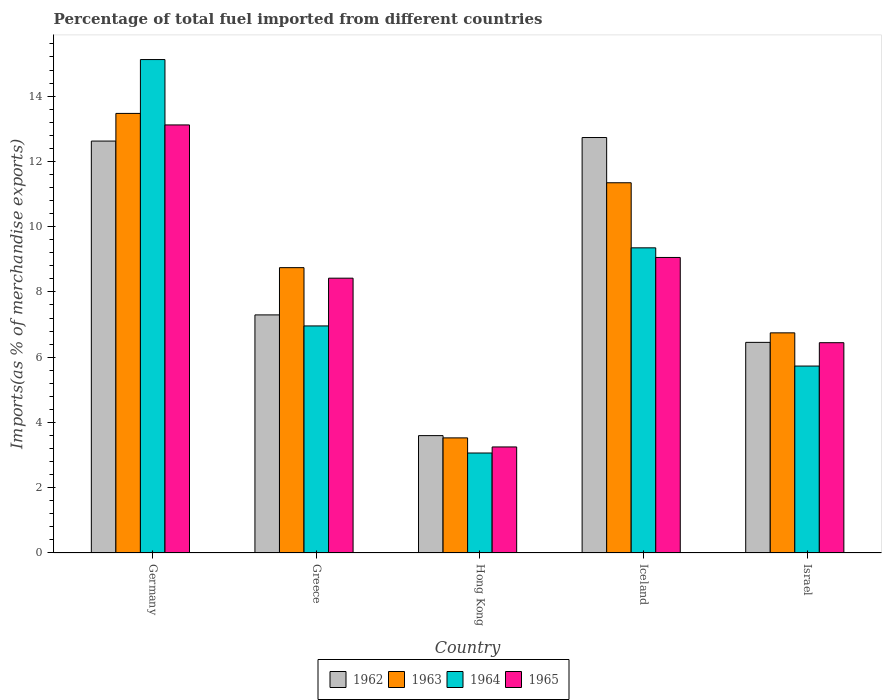How many groups of bars are there?
Provide a succinct answer. 5. Are the number of bars on each tick of the X-axis equal?
Make the answer very short. Yes. In how many cases, is the number of bars for a given country not equal to the number of legend labels?
Offer a very short reply. 0. What is the percentage of imports to different countries in 1962 in Germany?
Your response must be concise. 12.62. Across all countries, what is the maximum percentage of imports to different countries in 1965?
Provide a succinct answer. 13.12. Across all countries, what is the minimum percentage of imports to different countries in 1965?
Provide a succinct answer. 3.25. In which country was the percentage of imports to different countries in 1965 minimum?
Your answer should be compact. Hong Kong. What is the total percentage of imports to different countries in 1962 in the graph?
Offer a terse response. 42.7. What is the difference between the percentage of imports to different countries in 1962 in Greece and that in Israel?
Your response must be concise. 0.84. What is the difference between the percentage of imports to different countries in 1965 in Hong Kong and the percentage of imports to different countries in 1964 in Greece?
Your answer should be very brief. -3.71. What is the average percentage of imports to different countries in 1962 per country?
Your answer should be compact. 8.54. What is the difference between the percentage of imports to different countries of/in 1963 and percentage of imports to different countries of/in 1964 in Iceland?
Your response must be concise. 1.99. In how many countries, is the percentage of imports to different countries in 1963 greater than 7.2 %?
Make the answer very short. 3. What is the ratio of the percentage of imports to different countries in 1964 in Germany to that in Iceland?
Your answer should be very brief. 1.62. Is the difference between the percentage of imports to different countries in 1963 in Greece and Hong Kong greater than the difference between the percentage of imports to different countries in 1964 in Greece and Hong Kong?
Offer a very short reply. Yes. What is the difference between the highest and the second highest percentage of imports to different countries in 1964?
Provide a succinct answer. 2.39. What is the difference between the highest and the lowest percentage of imports to different countries in 1965?
Ensure brevity in your answer.  9.87. In how many countries, is the percentage of imports to different countries in 1965 greater than the average percentage of imports to different countries in 1965 taken over all countries?
Provide a succinct answer. 3. Is the sum of the percentage of imports to different countries in 1963 in Greece and Israel greater than the maximum percentage of imports to different countries in 1964 across all countries?
Keep it short and to the point. Yes. Is it the case that in every country, the sum of the percentage of imports to different countries in 1965 and percentage of imports to different countries in 1963 is greater than the sum of percentage of imports to different countries in 1964 and percentage of imports to different countries in 1962?
Ensure brevity in your answer.  No. What does the 4th bar from the left in Iceland represents?
Provide a short and direct response. 1965. What does the 2nd bar from the right in Hong Kong represents?
Offer a very short reply. 1964. Is it the case that in every country, the sum of the percentage of imports to different countries in 1964 and percentage of imports to different countries in 1962 is greater than the percentage of imports to different countries in 1963?
Your answer should be very brief. Yes. How many bars are there?
Your response must be concise. 20. How many countries are there in the graph?
Provide a short and direct response. 5. Does the graph contain grids?
Ensure brevity in your answer.  No. How many legend labels are there?
Your answer should be very brief. 4. What is the title of the graph?
Provide a succinct answer. Percentage of total fuel imported from different countries. What is the label or title of the X-axis?
Provide a succinct answer. Country. What is the label or title of the Y-axis?
Ensure brevity in your answer.  Imports(as % of merchandise exports). What is the Imports(as % of merchandise exports) in 1962 in Germany?
Your answer should be very brief. 12.62. What is the Imports(as % of merchandise exports) in 1963 in Germany?
Ensure brevity in your answer.  13.47. What is the Imports(as % of merchandise exports) of 1964 in Germany?
Your answer should be compact. 15.12. What is the Imports(as % of merchandise exports) of 1965 in Germany?
Keep it short and to the point. 13.12. What is the Imports(as % of merchandise exports) of 1962 in Greece?
Your answer should be very brief. 7.3. What is the Imports(as % of merchandise exports) in 1963 in Greece?
Keep it short and to the point. 8.74. What is the Imports(as % of merchandise exports) of 1964 in Greece?
Provide a short and direct response. 6.96. What is the Imports(as % of merchandise exports) of 1965 in Greece?
Offer a terse response. 8.42. What is the Imports(as % of merchandise exports) in 1962 in Hong Kong?
Ensure brevity in your answer.  3.6. What is the Imports(as % of merchandise exports) of 1963 in Hong Kong?
Provide a short and direct response. 3.53. What is the Imports(as % of merchandise exports) of 1964 in Hong Kong?
Offer a terse response. 3.06. What is the Imports(as % of merchandise exports) in 1965 in Hong Kong?
Give a very brief answer. 3.25. What is the Imports(as % of merchandise exports) of 1962 in Iceland?
Your response must be concise. 12.73. What is the Imports(as % of merchandise exports) of 1963 in Iceland?
Make the answer very short. 11.35. What is the Imports(as % of merchandise exports) of 1964 in Iceland?
Provide a short and direct response. 9.35. What is the Imports(as % of merchandise exports) of 1965 in Iceland?
Make the answer very short. 9.06. What is the Imports(as % of merchandise exports) of 1962 in Israel?
Make the answer very short. 6.45. What is the Imports(as % of merchandise exports) of 1963 in Israel?
Your answer should be very brief. 6.75. What is the Imports(as % of merchandise exports) in 1964 in Israel?
Keep it short and to the point. 5.73. What is the Imports(as % of merchandise exports) of 1965 in Israel?
Make the answer very short. 6.44. Across all countries, what is the maximum Imports(as % of merchandise exports) of 1962?
Make the answer very short. 12.73. Across all countries, what is the maximum Imports(as % of merchandise exports) in 1963?
Offer a terse response. 13.47. Across all countries, what is the maximum Imports(as % of merchandise exports) in 1964?
Ensure brevity in your answer.  15.12. Across all countries, what is the maximum Imports(as % of merchandise exports) in 1965?
Your response must be concise. 13.12. Across all countries, what is the minimum Imports(as % of merchandise exports) in 1962?
Offer a very short reply. 3.6. Across all countries, what is the minimum Imports(as % of merchandise exports) in 1963?
Make the answer very short. 3.53. Across all countries, what is the minimum Imports(as % of merchandise exports) of 1964?
Make the answer very short. 3.06. Across all countries, what is the minimum Imports(as % of merchandise exports) in 1965?
Keep it short and to the point. 3.25. What is the total Imports(as % of merchandise exports) in 1962 in the graph?
Give a very brief answer. 42.7. What is the total Imports(as % of merchandise exports) in 1963 in the graph?
Give a very brief answer. 43.83. What is the total Imports(as % of merchandise exports) of 1964 in the graph?
Keep it short and to the point. 40.22. What is the total Imports(as % of merchandise exports) in 1965 in the graph?
Offer a terse response. 40.29. What is the difference between the Imports(as % of merchandise exports) of 1962 in Germany and that in Greece?
Provide a succinct answer. 5.33. What is the difference between the Imports(as % of merchandise exports) of 1963 in Germany and that in Greece?
Ensure brevity in your answer.  4.73. What is the difference between the Imports(as % of merchandise exports) of 1964 in Germany and that in Greece?
Keep it short and to the point. 8.16. What is the difference between the Imports(as % of merchandise exports) of 1965 in Germany and that in Greece?
Your answer should be compact. 4.7. What is the difference between the Imports(as % of merchandise exports) of 1962 in Germany and that in Hong Kong?
Ensure brevity in your answer.  9.03. What is the difference between the Imports(as % of merchandise exports) of 1963 in Germany and that in Hong Kong?
Your answer should be compact. 9.94. What is the difference between the Imports(as % of merchandise exports) of 1964 in Germany and that in Hong Kong?
Your answer should be very brief. 12.06. What is the difference between the Imports(as % of merchandise exports) of 1965 in Germany and that in Hong Kong?
Offer a very short reply. 9.87. What is the difference between the Imports(as % of merchandise exports) of 1962 in Germany and that in Iceland?
Ensure brevity in your answer.  -0.11. What is the difference between the Imports(as % of merchandise exports) of 1963 in Germany and that in Iceland?
Your answer should be compact. 2.13. What is the difference between the Imports(as % of merchandise exports) of 1964 in Germany and that in Iceland?
Ensure brevity in your answer.  5.77. What is the difference between the Imports(as % of merchandise exports) in 1965 in Germany and that in Iceland?
Give a very brief answer. 4.06. What is the difference between the Imports(as % of merchandise exports) of 1962 in Germany and that in Israel?
Your response must be concise. 6.17. What is the difference between the Imports(as % of merchandise exports) of 1963 in Germany and that in Israel?
Offer a very short reply. 6.72. What is the difference between the Imports(as % of merchandise exports) in 1964 in Germany and that in Israel?
Give a very brief answer. 9.39. What is the difference between the Imports(as % of merchandise exports) in 1965 in Germany and that in Israel?
Give a very brief answer. 6.67. What is the difference between the Imports(as % of merchandise exports) of 1962 in Greece and that in Hong Kong?
Give a very brief answer. 3.7. What is the difference between the Imports(as % of merchandise exports) of 1963 in Greece and that in Hong Kong?
Offer a very short reply. 5.22. What is the difference between the Imports(as % of merchandise exports) of 1964 in Greece and that in Hong Kong?
Your answer should be very brief. 3.89. What is the difference between the Imports(as % of merchandise exports) of 1965 in Greece and that in Hong Kong?
Your answer should be compact. 5.17. What is the difference between the Imports(as % of merchandise exports) of 1962 in Greece and that in Iceland?
Provide a short and direct response. -5.44. What is the difference between the Imports(as % of merchandise exports) in 1963 in Greece and that in Iceland?
Give a very brief answer. -2.6. What is the difference between the Imports(as % of merchandise exports) in 1964 in Greece and that in Iceland?
Ensure brevity in your answer.  -2.39. What is the difference between the Imports(as % of merchandise exports) in 1965 in Greece and that in Iceland?
Your answer should be very brief. -0.64. What is the difference between the Imports(as % of merchandise exports) in 1962 in Greece and that in Israel?
Your answer should be very brief. 0.84. What is the difference between the Imports(as % of merchandise exports) in 1963 in Greece and that in Israel?
Ensure brevity in your answer.  2. What is the difference between the Imports(as % of merchandise exports) in 1964 in Greece and that in Israel?
Make the answer very short. 1.23. What is the difference between the Imports(as % of merchandise exports) of 1965 in Greece and that in Israel?
Provide a succinct answer. 1.98. What is the difference between the Imports(as % of merchandise exports) of 1962 in Hong Kong and that in Iceland?
Offer a very short reply. -9.13. What is the difference between the Imports(as % of merchandise exports) in 1963 in Hong Kong and that in Iceland?
Offer a terse response. -7.82. What is the difference between the Imports(as % of merchandise exports) in 1964 in Hong Kong and that in Iceland?
Give a very brief answer. -6.29. What is the difference between the Imports(as % of merchandise exports) of 1965 in Hong Kong and that in Iceland?
Make the answer very short. -5.81. What is the difference between the Imports(as % of merchandise exports) of 1962 in Hong Kong and that in Israel?
Ensure brevity in your answer.  -2.86. What is the difference between the Imports(as % of merchandise exports) in 1963 in Hong Kong and that in Israel?
Offer a terse response. -3.22. What is the difference between the Imports(as % of merchandise exports) of 1964 in Hong Kong and that in Israel?
Provide a short and direct response. -2.66. What is the difference between the Imports(as % of merchandise exports) in 1965 in Hong Kong and that in Israel?
Give a very brief answer. -3.19. What is the difference between the Imports(as % of merchandise exports) in 1962 in Iceland and that in Israel?
Your response must be concise. 6.28. What is the difference between the Imports(as % of merchandise exports) in 1963 in Iceland and that in Israel?
Ensure brevity in your answer.  4.6. What is the difference between the Imports(as % of merchandise exports) of 1964 in Iceland and that in Israel?
Offer a very short reply. 3.62. What is the difference between the Imports(as % of merchandise exports) in 1965 in Iceland and that in Israel?
Your answer should be very brief. 2.61. What is the difference between the Imports(as % of merchandise exports) of 1962 in Germany and the Imports(as % of merchandise exports) of 1963 in Greece?
Offer a very short reply. 3.88. What is the difference between the Imports(as % of merchandise exports) in 1962 in Germany and the Imports(as % of merchandise exports) in 1964 in Greece?
Provide a succinct answer. 5.66. What is the difference between the Imports(as % of merchandise exports) of 1962 in Germany and the Imports(as % of merchandise exports) of 1965 in Greece?
Keep it short and to the point. 4.2. What is the difference between the Imports(as % of merchandise exports) of 1963 in Germany and the Imports(as % of merchandise exports) of 1964 in Greece?
Offer a terse response. 6.51. What is the difference between the Imports(as % of merchandise exports) in 1963 in Germany and the Imports(as % of merchandise exports) in 1965 in Greece?
Make the answer very short. 5.05. What is the difference between the Imports(as % of merchandise exports) in 1964 in Germany and the Imports(as % of merchandise exports) in 1965 in Greece?
Offer a terse response. 6.7. What is the difference between the Imports(as % of merchandise exports) of 1962 in Germany and the Imports(as % of merchandise exports) of 1963 in Hong Kong?
Make the answer very short. 9.1. What is the difference between the Imports(as % of merchandise exports) of 1962 in Germany and the Imports(as % of merchandise exports) of 1964 in Hong Kong?
Offer a terse response. 9.56. What is the difference between the Imports(as % of merchandise exports) of 1962 in Germany and the Imports(as % of merchandise exports) of 1965 in Hong Kong?
Make the answer very short. 9.37. What is the difference between the Imports(as % of merchandise exports) of 1963 in Germany and the Imports(as % of merchandise exports) of 1964 in Hong Kong?
Your answer should be compact. 10.41. What is the difference between the Imports(as % of merchandise exports) of 1963 in Germany and the Imports(as % of merchandise exports) of 1965 in Hong Kong?
Your response must be concise. 10.22. What is the difference between the Imports(as % of merchandise exports) of 1964 in Germany and the Imports(as % of merchandise exports) of 1965 in Hong Kong?
Make the answer very short. 11.87. What is the difference between the Imports(as % of merchandise exports) in 1962 in Germany and the Imports(as % of merchandise exports) in 1963 in Iceland?
Your answer should be very brief. 1.28. What is the difference between the Imports(as % of merchandise exports) of 1962 in Germany and the Imports(as % of merchandise exports) of 1964 in Iceland?
Your response must be concise. 3.27. What is the difference between the Imports(as % of merchandise exports) in 1962 in Germany and the Imports(as % of merchandise exports) in 1965 in Iceland?
Make the answer very short. 3.57. What is the difference between the Imports(as % of merchandise exports) of 1963 in Germany and the Imports(as % of merchandise exports) of 1964 in Iceland?
Provide a succinct answer. 4.12. What is the difference between the Imports(as % of merchandise exports) of 1963 in Germany and the Imports(as % of merchandise exports) of 1965 in Iceland?
Keep it short and to the point. 4.41. What is the difference between the Imports(as % of merchandise exports) of 1964 in Germany and the Imports(as % of merchandise exports) of 1965 in Iceland?
Provide a succinct answer. 6.06. What is the difference between the Imports(as % of merchandise exports) of 1962 in Germany and the Imports(as % of merchandise exports) of 1963 in Israel?
Your response must be concise. 5.88. What is the difference between the Imports(as % of merchandise exports) of 1962 in Germany and the Imports(as % of merchandise exports) of 1964 in Israel?
Offer a terse response. 6.89. What is the difference between the Imports(as % of merchandise exports) of 1962 in Germany and the Imports(as % of merchandise exports) of 1965 in Israel?
Your answer should be very brief. 6.18. What is the difference between the Imports(as % of merchandise exports) of 1963 in Germany and the Imports(as % of merchandise exports) of 1964 in Israel?
Provide a succinct answer. 7.74. What is the difference between the Imports(as % of merchandise exports) in 1963 in Germany and the Imports(as % of merchandise exports) in 1965 in Israel?
Keep it short and to the point. 7.03. What is the difference between the Imports(as % of merchandise exports) in 1964 in Germany and the Imports(as % of merchandise exports) in 1965 in Israel?
Make the answer very short. 8.68. What is the difference between the Imports(as % of merchandise exports) in 1962 in Greece and the Imports(as % of merchandise exports) in 1963 in Hong Kong?
Provide a short and direct response. 3.77. What is the difference between the Imports(as % of merchandise exports) of 1962 in Greece and the Imports(as % of merchandise exports) of 1964 in Hong Kong?
Your answer should be compact. 4.23. What is the difference between the Imports(as % of merchandise exports) in 1962 in Greece and the Imports(as % of merchandise exports) in 1965 in Hong Kong?
Give a very brief answer. 4.05. What is the difference between the Imports(as % of merchandise exports) in 1963 in Greece and the Imports(as % of merchandise exports) in 1964 in Hong Kong?
Provide a succinct answer. 5.68. What is the difference between the Imports(as % of merchandise exports) in 1963 in Greece and the Imports(as % of merchandise exports) in 1965 in Hong Kong?
Your response must be concise. 5.49. What is the difference between the Imports(as % of merchandise exports) of 1964 in Greece and the Imports(as % of merchandise exports) of 1965 in Hong Kong?
Your answer should be very brief. 3.71. What is the difference between the Imports(as % of merchandise exports) in 1962 in Greece and the Imports(as % of merchandise exports) in 1963 in Iceland?
Provide a short and direct response. -4.05. What is the difference between the Imports(as % of merchandise exports) of 1962 in Greece and the Imports(as % of merchandise exports) of 1964 in Iceland?
Your response must be concise. -2.06. What is the difference between the Imports(as % of merchandise exports) in 1962 in Greece and the Imports(as % of merchandise exports) in 1965 in Iceland?
Provide a succinct answer. -1.76. What is the difference between the Imports(as % of merchandise exports) of 1963 in Greece and the Imports(as % of merchandise exports) of 1964 in Iceland?
Give a very brief answer. -0.61. What is the difference between the Imports(as % of merchandise exports) in 1963 in Greece and the Imports(as % of merchandise exports) in 1965 in Iceland?
Your response must be concise. -0.31. What is the difference between the Imports(as % of merchandise exports) in 1964 in Greece and the Imports(as % of merchandise exports) in 1965 in Iceland?
Provide a short and direct response. -2.1. What is the difference between the Imports(as % of merchandise exports) of 1962 in Greece and the Imports(as % of merchandise exports) of 1963 in Israel?
Offer a very short reply. 0.55. What is the difference between the Imports(as % of merchandise exports) of 1962 in Greece and the Imports(as % of merchandise exports) of 1964 in Israel?
Make the answer very short. 1.57. What is the difference between the Imports(as % of merchandise exports) in 1962 in Greece and the Imports(as % of merchandise exports) in 1965 in Israel?
Give a very brief answer. 0.85. What is the difference between the Imports(as % of merchandise exports) of 1963 in Greece and the Imports(as % of merchandise exports) of 1964 in Israel?
Provide a short and direct response. 3.02. What is the difference between the Imports(as % of merchandise exports) in 1964 in Greece and the Imports(as % of merchandise exports) in 1965 in Israel?
Provide a succinct answer. 0.51. What is the difference between the Imports(as % of merchandise exports) in 1962 in Hong Kong and the Imports(as % of merchandise exports) in 1963 in Iceland?
Your answer should be very brief. -7.75. What is the difference between the Imports(as % of merchandise exports) in 1962 in Hong Kong and the Imports(as % of merchandise exports) in 1964 in Iceland?
Give a very brief answer. -5.75. What is the difference between the Imports(as % of merchandise exports) in 1962 in Hong Kong and the Imports(as % of merchandise exports) in 1965 in Iceland?
Provide a short and direct response. -5.46. What is the difference between the Imports(as % of merchandise exports) of 1963 in Hong Kong and the Imports(as % of merchandise exports) of 1964 in Iceland?
Offer a very short reply. -5.82. What is the difference between the Imports(as % of merchandise exports) in 1963 in Hong Kong and the Imports(as % of merchandise exports) in 1965 in Iceland?
Provide a short and direct response. -5.53. What is the difference between the Imports(as % of merchandise exports) of 1964 in Hong Kong and the Imports(as % of merchandise exports) of 1965 in Iceland?
Make the answer very short. -5.99. What is the difference between the Imports(as % of merchandise exports) in 1962 in Hong Kong and the Imports(as % of merchandise exports) in 1963 in Israel?
Provide a short and direct response. -3.15. What is the difference between the Imports(as % of merchandise exports) in 1962 in Hong Kong and the Imports(as % of merchandise exports) in 1964 in Israel?
Provide a succinct answer. -2.13. What is the difference between the Imports(as % of merchandise exports) in 1962 in Hong Kong and the Imports(as % of merchandise exports) in 1965 in Israel?
Offer a very short reply. -2.85. What is the difference between the Imports(as % of merchandise exports) of 1963 in Hong Kong and the Imports(as % of merchandise exports) of 1964 in Israel?
Provide a short and direct response. -2.2. What is the difference between the Imports(as % of merchandise exports) of 1963 in Hong Kong and the Imports(as % of merchandise exports) of 1965 in Israel?
Provide a succinct answer. -2.92. What is the difference between the Imports(as % of merchandise exports) in 1964 in Hong Kong and the Imports(as % of merchandise exports) in 1965 in Israel?
Keep it short and to the point. -3.38. What is the difference between the Imports(as % of merchandise exports) in 1962 in Iceland and the Imports(as % of merchandise exports) in 1963 in Israel?
Your response must be concise. 5.99. What is the difference between the Imports(as % of merchandise exports) of 1962 in Iceland and the Imports(as % of merchandise exports) of 1964 in Israel?
Keep it short and to the point. 7. What is the difference between the Imports(as % of merchandise exports) of 1962 in Iceland and the Imports(as % of merchandise exports) of 1965 in Israel?
Your answer should be compact. 6.29. What is the difference between the Imports(as % of merchandise exports) of 1963 in Iceland and the Imports(as % of merchandise exports) of 1964 in Israel?
Your answer should be very brief. 5.62. What is the difference between the Imports(as % of merchandise exports) of 1963 in Iceland and the Imports(as % of merchandise exports) of 1965 in Israel?
Your response must be concise. 4.9. What is the difference between the Imports(as % of merchandise exports) in 1964 in Iceland and the Imports(as % of merchandise exports) in 1965 in Israel?
Your response must be concise. 2.91. What is the average Imports(as % of merchandise exports) of 1962 per country?
Offer a very short reply. 8.54. What is the average Imports(as % of merchandise exports) of 1963 per country?
Provide a short and direct response. 8.77. What is the average Imports(as % of merchandise exports) in 1964 per country?
Ensure brevity in your answer.  8.04. What is the average Imports(as % of merchandise exports) in 1965 per country?
Ensure brevity in your answer.  8.06. What is the difference between the Imports(as % of merchandise exports) in 1962 and Imports(as % of merchandise exports) in 1963 in Germany?
Your answer should be compact. -0.85. What is the difference between the Imports(as % of merchandise exports) in 1962 and Imports(as % of merchandise exports) in 1964 in Germany?
Ensure brevity in your answer.  -2.5. What is the difference between the Imports(as % of merchandise exports) of 1962 and Imports(as % of merchandise exports) of 1965 in Germany?
Offer a very short reply. -0.49. What is the difference between the Imports(as % of merchandise exports) of 1963 and Imports(as % of merchandise exports) of 1964 in Germany?
Offer a very short reply. -1.65. What is the difference between the Imports(as % of merchandise exports) in 1963 and Imports(as % of merchandise exports) in 1965 in Germany?
Your response must be concise. 0.35. What is the difference between the Imports(as % of merchandise exports) of 1964 and Imports(as % of merchandise exports) of 1965 in Germany?
Your answer should be very brief. 2. What is the difference between the Imports(as % of merchandise exports) of 1962 and Imports(as % of merchandise exports) of 1963 in Greece?
Make the answer very short. -1.45. What is the difference between the Imports(as % of merchandise exports) in 1962 and Imports(as % of merchandise exports) in 1964 in Greece?
Make the answer very short. 0.34. What is the difference between the Imports(as % of merchandise exports) of 1962 and Imports(as % of merchandise exports) of 1965 in Greece?
Ensure brevity in your answer.  -1.13. What is the difference between the Imports(as % of merchandise exports) of 1963 and Imports(as % of merchandise exports) of 1964 in Greece?
Keep it short and to the point. 1.79. What is the difference between the Imports(as % of merchandise exports) of 1963 and Imports(as % of merchandise exports) of 1965 in Greece?
Ensure brevity in your answer.  0.32. What is the difference between the Imports(as % of merchandise exports) in 1964 and Imports(as % of merchandise exports) in 1965 in Greece?
Provide a succinct answer. -1.46. What is the difference between the Imports(as % of merchandise exports) of 1962 and Imports(as % of merchandise exports) of 1963 in Hong Kong?
Make the answer very short. 0.07. What is the difference between the Imports(as % of merchandise exports) in 1962 and Imports(as % of merchandise exports) in 1964 in Hong Kong?
Provide a short and direct response. 0.53. What is the difference between the Imports(as % of merchandise exports) of 1962 and Imports(as % of merchandise exports) of 1965 in Hong Kong?
Ensure brevity in your answer.  0.35. What is the difference between the Imports(as % of merchandise exports) of 1963 and Imports(as % of merchandise exports) of 1964 in Hong Kong?
Your response must be concise. 0.46. What is the difference between the Imports(as % of merchandise exports) in 1963 and Imports(as % of merchandise exports) in 1965 in Hong Kong?
Offer a terse response. 0.28. What is the difference between the Imports(as % of merchandise exports) of 1964 and Imports(as % of merchandise exports) of 1965 in Hong Kong?
Make the answer very short. -0.19. What is the difference between the Imports(as % of merchandise exports) in 1962 and Imports(as % of merchandise exports) in 1963 in Iceland?
Provide a short and direct response. 1.39. What is the difference between the Imports(as % of merchandise exports) in 1962 and Imports(as % of merchandise exports) in 1964 in Iceland?
Your answer should be very brief. 3.38. What is the difference between the Imports(as % of merchandise exports) in 1962 and Imports(as % of merchandise exports) in 1965 in Iceland?
Make the answer very short. 3.67. What is the difference between the Imports(as % of merchandise exports) in 1963 and Imports(as % of merchandise exports) in 1964 in Iceland?
Your answer should be very brief. 1.99. What is the difference between the Imports(as % of merchandise exports) in 1963 and Imports(as % of merchandise exports) in 1965 in Iceland?
Keep it short and to the point. 2.29. What is the difference between the Imports(as % of merchandise exports) in 1964 and Imports(as % of merchandise exports) in 1965 in Iceland?
Provide a short and direct response. 0.29. What is the difference between the Imports(as % of merchandise exports) in 1962 and Imports(as % of merchandise exports) in 1963 in Israel?
Ensure brevity in your answer.  -0.29. What is the difference between the Imports(as % of merchandise exports) in 1962 and Imports(as % of merchandise exports) in 1964 in Israel?
Provide a short and direct response. 0.73. What is the difference between the Imports(as % of merchandise exports) in 1962 and Imports(as % of merchandise exports) in 1965 in Israel?
Provide a succinct answer. 0.01. What is the difference between the Imports(as % of merchandise exports) of 1963 and Imports(as % of merchandise exports) of 1964 in Israel?
Ensure brevity in your answer.  1.02. What is the difference between the Imports(as % of merchandise exports) in 1963 and Imports(as % of merchandise exports) in 1965 in Israel?
Your answer should be compact. 0.3. What is the difference between the Imports(as % of merchandise exports) in 1964 and Imports(as % of merchandise exports) in 1965 in Israel?
Provide a succinct answer. -0.72. What is the ratio of the Imports(as % of merchandise exports) in 1962 in Germany to that in Greece?
Ensure brevity in your answer.  1.73. What is the ratio of the Imports(as % of merchandise exports) of 1963 in Germany to that in Greece?
Your answer should be compact. 1.54. What is the ratio of the Imports(as % of merchandise exports) in 1964 in Germany to that in Greece?
Give a very brief answer. 2.17. What is the ratio of the Imports(as % of merchandise exports) of 1965 in Germany to that in Greece?
Make the answer very short. 1.56. What is the ratio of the Imports(as % of merchandise exports) of 1962 in Germany to that in Hong Kong?
Ensure brevity in your answer.  3.51. What is the ratio of the Imports(as % of merchandise exports) in 1963 in Germany to that in Hong Kong?
Ensure brevity in your answer.  3.82. What is the ratio of the Imports(as % of merchandise exports) of 1964 in Germany to that in Hong Kong?
Your answer should be very brief. 4.94. What is the ratio of the Imports(as % of merchandise exports) of 1965 in Germany to that in Hong Kong?
Keep it short and to the point. 4.04. What is the ratio of the Imports(as % of merchandise exports) in 1962 in Germany to that in Iceland?
Offer a very short reply. 0.99. What is the ratio of the Imports(as % of merchandise exports) in 1963 in Germany to that in Iceland?
Your answer should be compact. 1.19. What is the ratio of the Imports(as % of merchandise exports) of 1964 in Germany to that in Iceland?
Your answer should be compact. 1.62. What is the ratio of the Imports(as % of merchandise exports) of 1965 in Germany to that in Iceland?
Your answer should be very brief. 1.45. What is the ratio of the Imports(as % of merchandise exports) in 1962 in Germany to that in Israel?
Make the answer very short. 1.96. What is the ratio of the Imports(as % of merchandise exports) in 1963 in Germany to that in Israel?
Offer a terse response. 2. What is the ratio of the Imports(as % of merchandise exports) of 1964 in Germany to that in Israel?
Your answer should be very brief. 2.64. What is the ratio of the Imports(as % of merchandise exports) of 1965 in Germany to that in Israel?
Your answer should be compact. 2.04. What is the ratio of the Imports(as % of merchandise exports) of 1962 in Greece to that in Hong Kong?
Offer a terse response. 2.03. What is the ratio of the Imports(as % of merchandise exports) in 1963 in Greece to that in Hong Kong?
Your response must be concise. 2.48. What is the ratio of the Imports(as % of merchandise exports) in 1964 in Greece to that in Hong Kong?
Your answer should be compact. 2.27. What is the ratio of the Imports(as % of merchandise exports) of 1965 in Greece to that in Hong Kong?
Provide a short and direct response. 2.59. What is the ratio of the Imports(as % of merchandise exports) of 1962 in Greece to that in Iceland?
Give a very brief answer. 0.57. What is the ratio of the Imports(as % of merchandise exports) in 1963 in Greece to that in Iceland?
Ensure brevity in your answer.  0.77. What is the ratio of the Imports(as % of merchandise exports) of 1964 in Greece to that in Iceland?
Keep it short and to the point. 0.74. What is the ratio of the Imports(as % of merchandise exports) in 1965 in Greece to that in Iceland?
Provide a short and direct response. 0.93. What is the ratio of the Imports(as % of merchandise exports) of 1962 in Greece to that in Israel?
Make the answer very short. 1.13. What is the ratio of the Imports(as % of merchandise exports) in 1963 in Greece to that in Israel?
Provide a succinct answer. 1.3. What is the ratio of the Imports(as % of merchandise exports) in 1964 in Greece to that in Israel?
Your response must be concise. 1.21. What is the ratio of the Imports(as % of merchandise exports) in 1965 in Greece to that in Israel?
Provide a succinct answer. 1.31. What is the ratio of the Imports(as % of merchandise exports) of 1962 in Hong Kong to that in Iceland?
Your response must be concise. 0.28. What is the ratio of the Imports(as % of merchandise exports) of 1963 in Hong Kong to that in Iceland?
Offer a very short reply. 0.31. What is the ratio of the Imports(as % of merchandise exports) of 1964 in Hong Kong to that in Iceland?
Your answer should be very brief. 0.33. What is the ratio of the Imports(as % of merchandise exports) of 1965 in Hong Kong to that in Iceland?
Your answer should be compact. 0.36. What is the ratio of the Imports(as % of merchandise exports) of 1962 in Hong Kong to that in Israel?
Offer a very short reply. 0.56. What is the ratio of the Imports(as % of merchandise exports) in 1963 in Hong Kong to that in Israel?
Keep it short and to the point. 0.52. What is the ratio of the Imports(as % of merchandise exports) of 1964 in Hong Kong to that in Israel?
Offer a very short reply. 0.53. What is the ratio of the Imports(as % of merchandise exports) in 1965 in Hong Kong to that in Israel?
Provide a short and direct response. 0.5. What is the ratio of the Imports(as % of merchandise exports) in 1962 in Iceland to that in Israel?
Make the answer very short. 1.97. What is the ratio of the Imports(as % of merchandise exports) in 1963 in Iceland to that in Israel?
Offer a terse response. 1.68. What is the ratio of the Imports(as % of merchandise exports) in 1964 in Iceland to that in Israel?
Give a very brief answer. 1.63. What is the ratio of the Imports(as % of merchandise exports) of 1965 in Iceland to that in Israel?
Your answer should be very brief. 1.41. What is the difference between the highest and the second highest Imports(as % of merchandise exports) in 1962?
Offer a terse response. 0.11. What is the difference between the highest and the second highest Imports(as % of merchandise exports) in 1963?
Keep it short and to the point. 2.13. What is the difference between the highest and the second highest Imports(as % of merchandise exports) in 1964?
Provide a succinct answer. 5.77. What is the difference between the highest and the second highest Imports(as % of merchandise exports) in 1965?
Your response must be concise. 4.06. What is the difference between the highest and the lowest Imports(as % of merchandise exports) of 1962?
Offer a terse response. 9.13. What is the difference between the highest and the lowest Imports(as % of merchandise exports) of 1963?
Your answer should be very brief. 9.94. What is the difference between the highest and the lowest Imports(as % of merchandise exports) in 1964?
Keep it short and to the point. 12.06. What is the difference between the highest and the lowest Imports(as % of merchandise exports) of 1965?
Offer a very short reply. 9.87. 